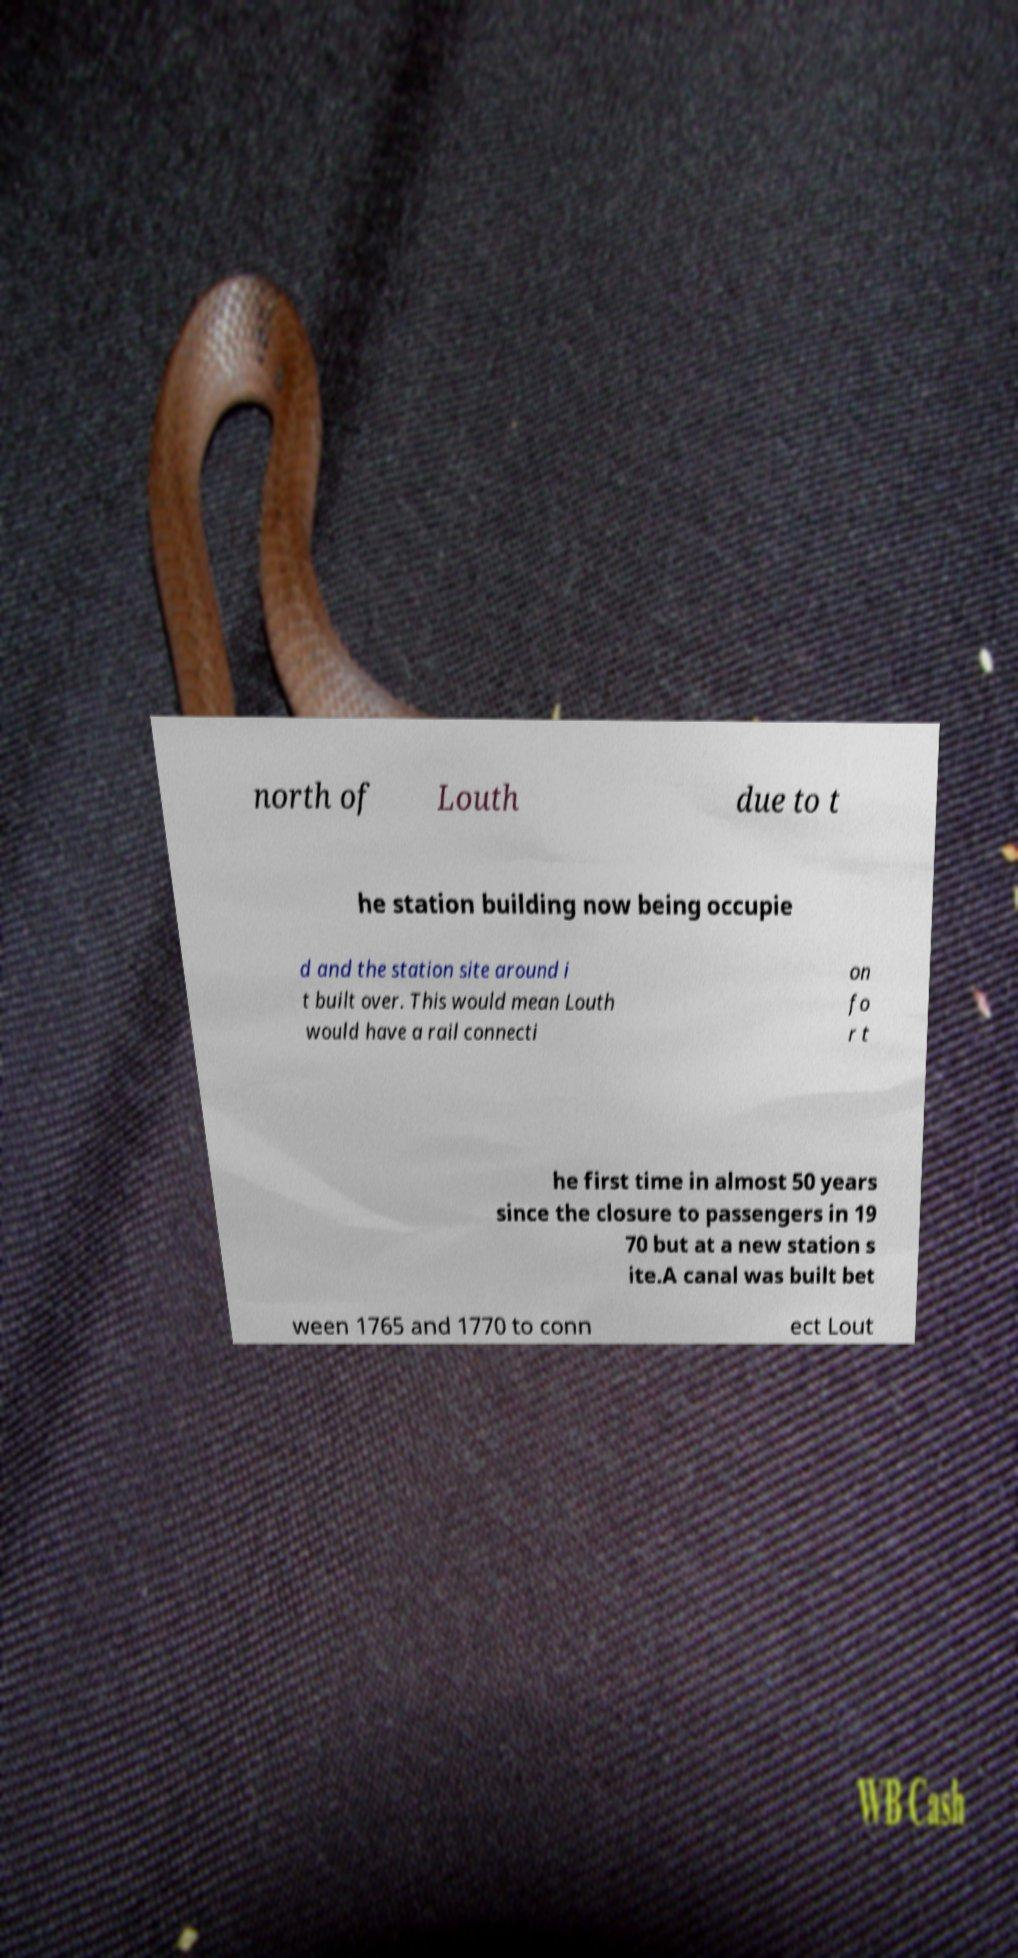Please read and relay the text visible in this image. What does it say? north of Louth due to t he station building now being occupie d and the station site around i t built over. This would mean Louth would have a rail connecti on fo r t he first time in almost 50 years since the closure to passengers in 19 70 but at a new station s ite.A canal was built bet ween 1765 and 1770 to conn ect Lout 